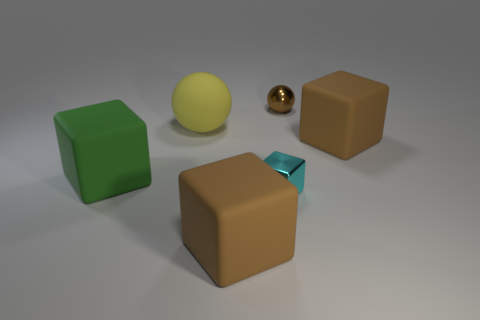Add 4 large red matte things. How many objects exist? 10 Subtract all cubes. How many objects are left? 2 Subtract all tiny yellow shiny balls. Subtract all large green cubes. How many objects are left? 5 Add 4 tiny cyan objects. How many tiny cyan objects are left? 5 Add 3 small purple rubber objects. How many small purple rubber objects exist? 3 Subtract 0 red spheres. How many objects are left? 6 